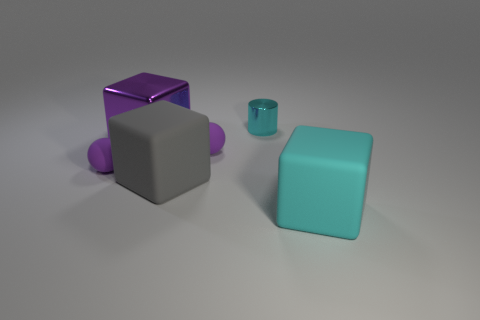Add 2 big cyan rubber cubes. How many objects exist? 8 Subtract all spheres. How many objects are left? 4 Add 5 small green metal things. How many small green metal things exist? 5 Subtract 0 yellow cubes. How many objects are left? 6 Subtract all tiny brown metal balls. Subtract all metal cubes. How many objects are left? 5 Add 1 big cyan objects. How many big cyan objects are left? 2 